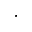Convert formula to latex. <formula><loc_0><loc_0><loc_500><loc_500>\cdot</formula> 